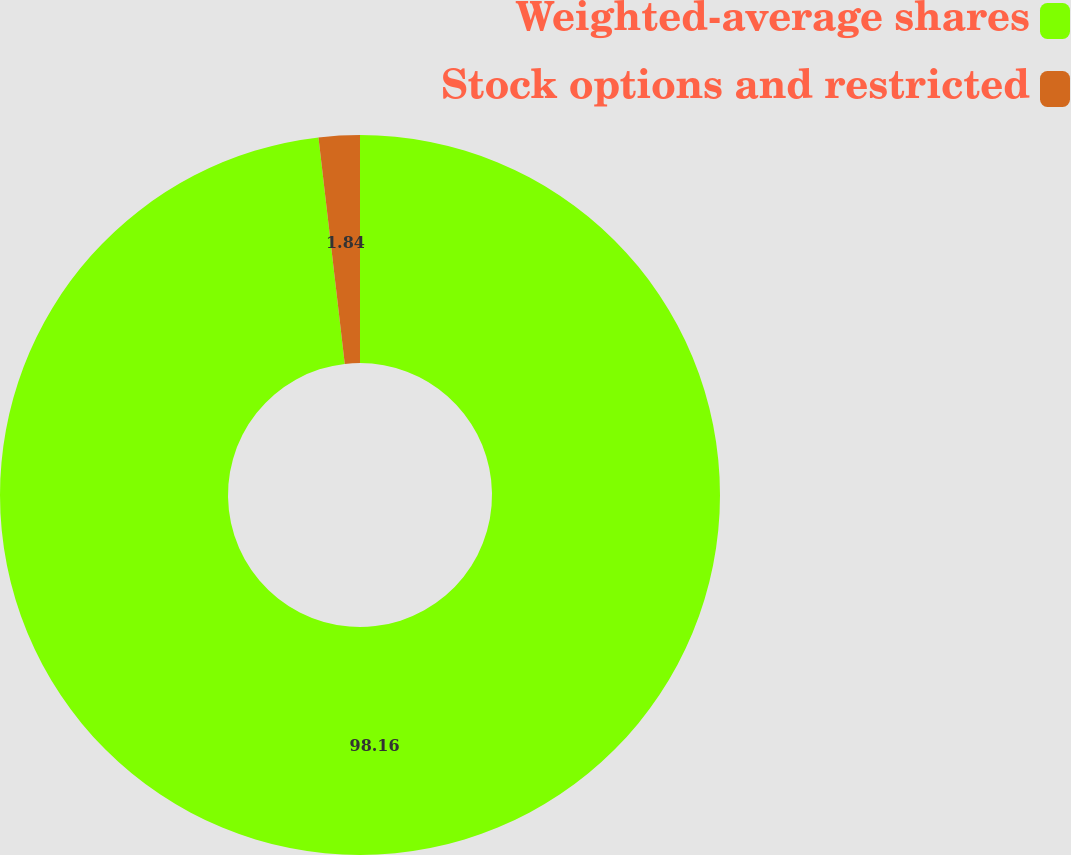Convert chart. <chart><loc_0><loc_0><loc_500><loc_500><pie_chart><fcel>Weighted-average shares<fcel>Stock options and restricted<nl><fcel>98.16%<fcel>1.84%<nl></chart> 